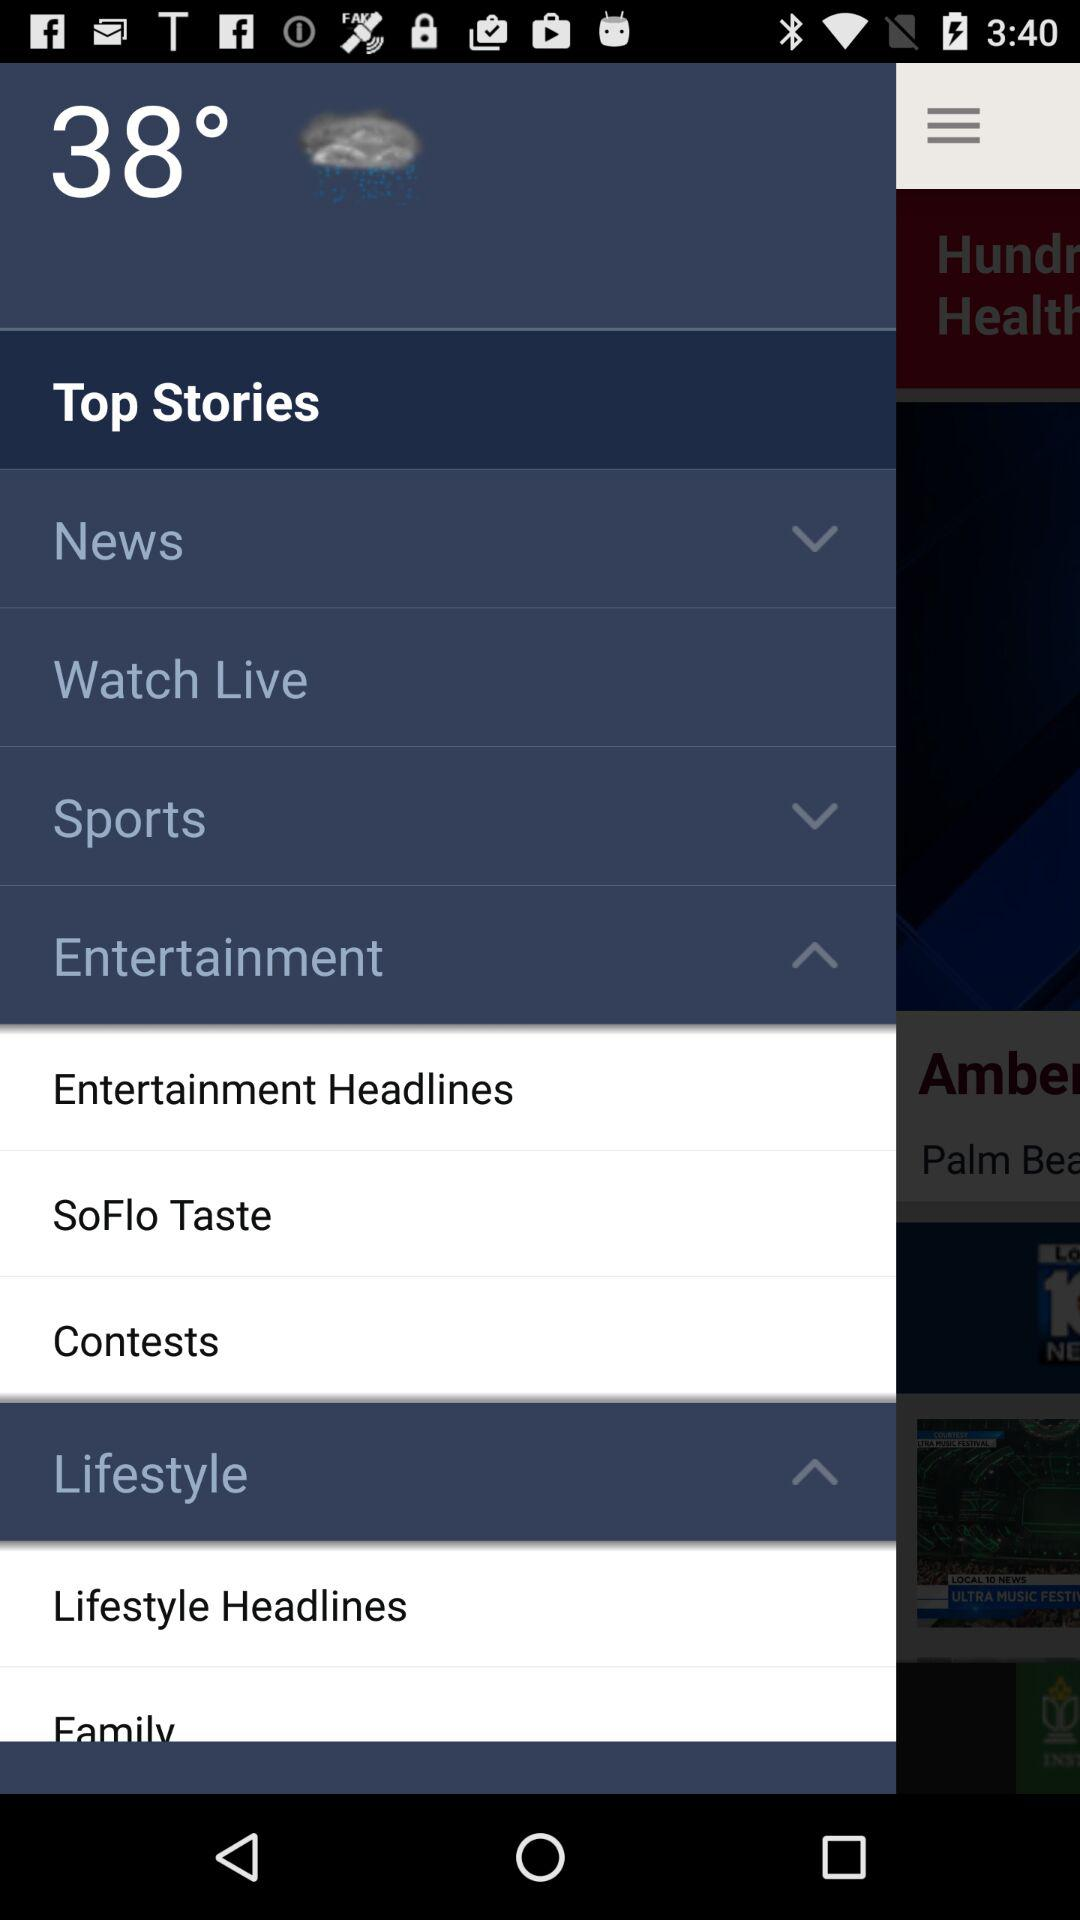What kind of weather is depicted?
When the provided information is insufficient, respond with <no answer>. <no answer> 